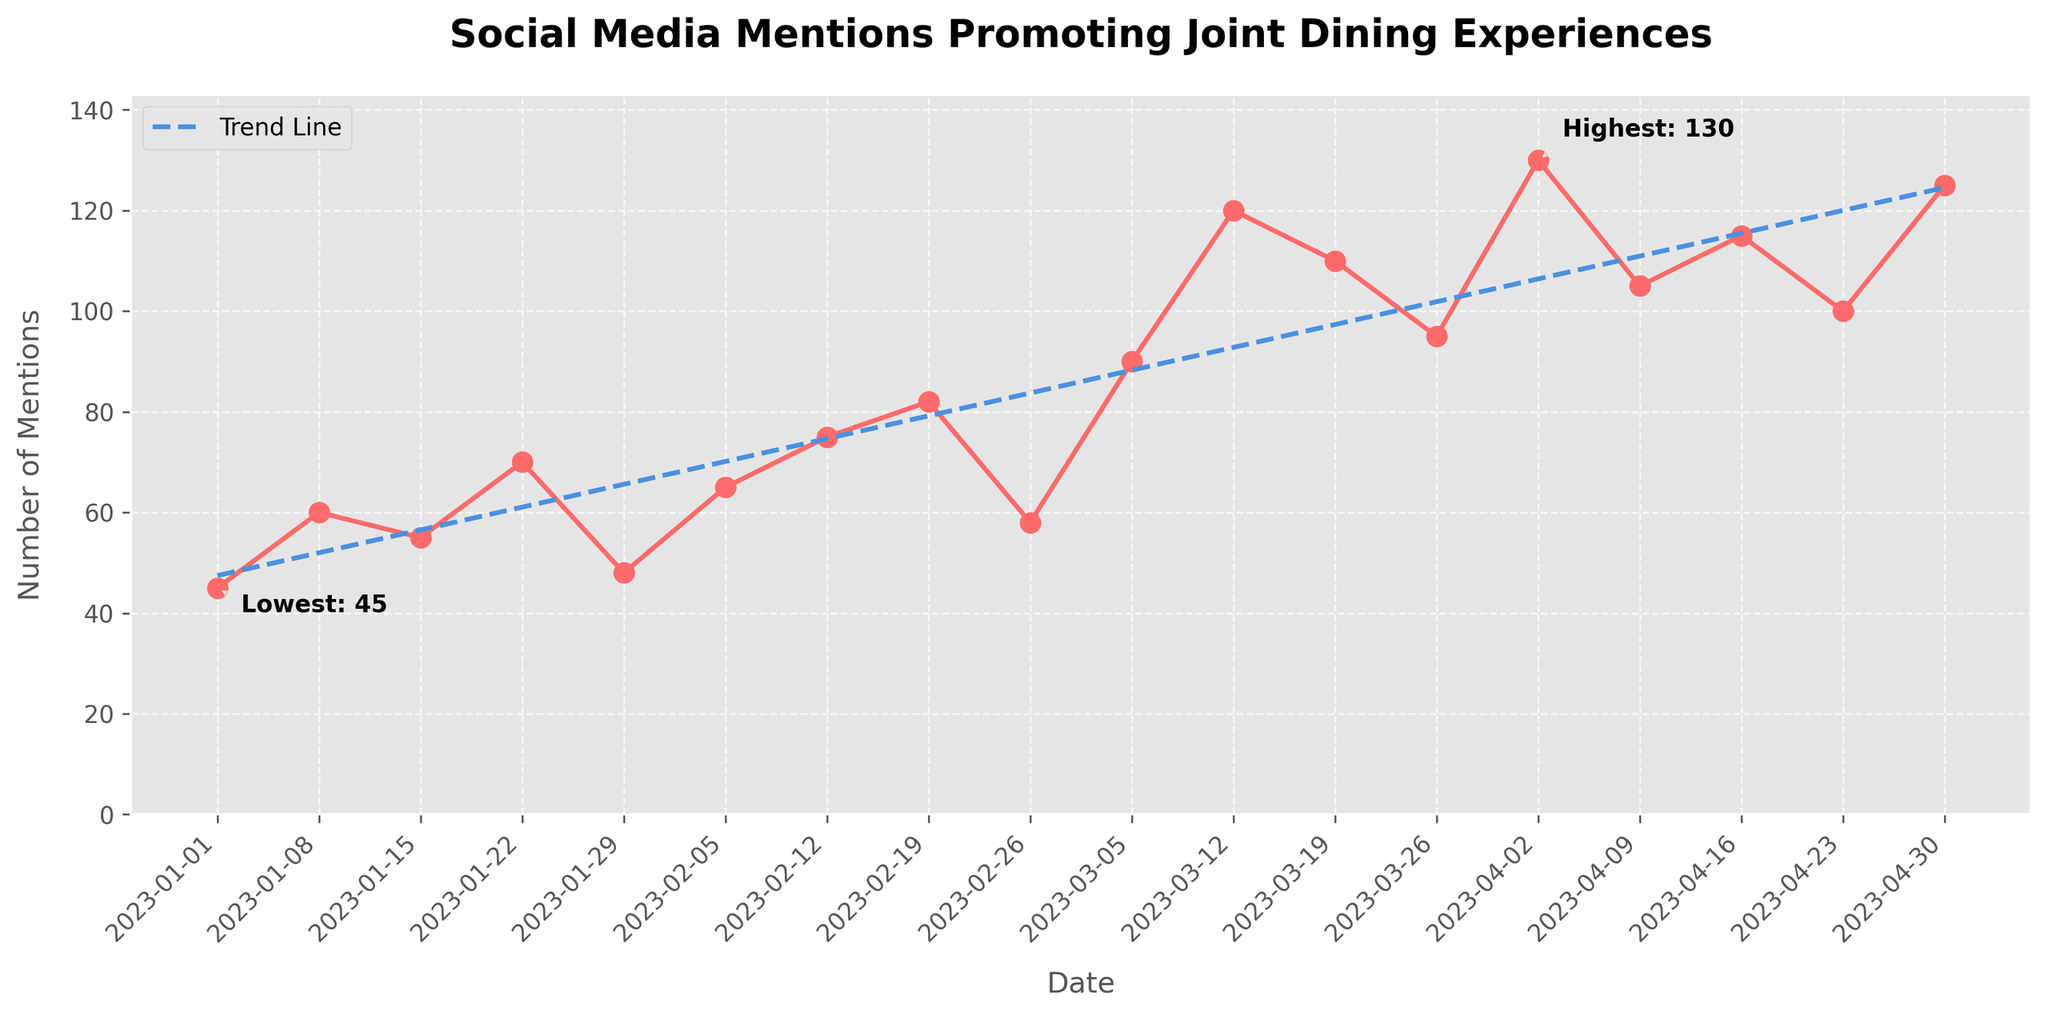What is the title of the plot? The title of the plot is prominently mentioned at the top and indicates what the plot is about.
Answer: "Social Media Mentions Promoting Joint Dining Experiences" How many times does the plot have data points for mentions? By counting the number of markers (data points) on the plot, we can determine the total instances of mentions.
Answer: 18 When did the highest number of mentions occur? The highest number of mentions is highlighted by an annotation pointing to the date on the plot.
Answer: Around "2023-04-02" What value corresponds to the lowest number of mentions? The lowest number of mentions is annotated on the plot, with both date and count visible.
Answer: 45 Is there an increasing trend in the number of mentions? By observing the overall direction of the trend line, we can determine if there is an increasing trend. The plotted trend line (dashed) generally shows an upward slant.
Answer: Yes What is the average number of mentions across the data points? Sum all the mentions and divide by the number of data points: (45+60+55+70+48+65+75+82+58+90+120+110+95+130+105+115+100+125) / 18
Answer: 84 What was the difference in mentions between the first and the last data points? Subtract the mentions on the first date (2023-01-01: 45) from the mentions on the last date (2023-04-30: 125).
Answer: 80 Does any specific week have a significant peak or drop compared to the neighboring weeks? By examining the plotted line and markers, significant peaks or drops can be spotted, such as the drop from 75 to 58 around "2023-02-26".
Answer: Yes, "2023-02-26" has a notable drop From February to March, did mentions generally increase or decrease? By checking the plot from February to March dates, we can follow the trend line between the points and see if it generally slopes upward or downward.
Answer: Increase Which period had more mentions: February or March? Total mentions in February (65+75+82+58) = 280; in March (90+120+110+95) = 415. Compare these sums to answer the question.
Answer: March 